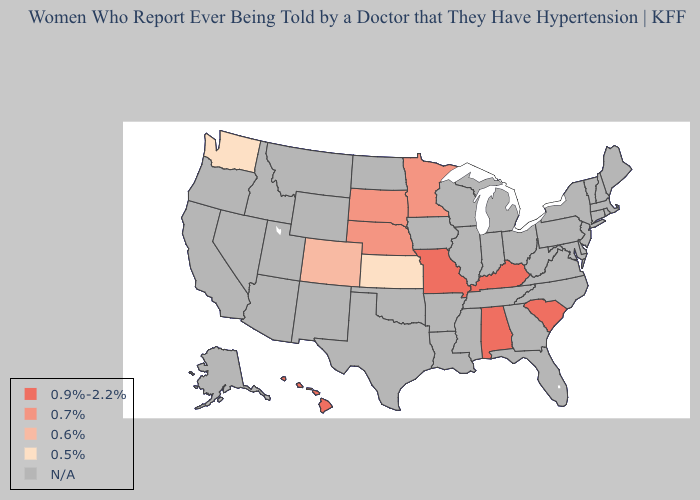What is the lowest value in the USA?
Quick response, please. 0.5%. Does Hawaii have the lowest value in the West?
Be succinct. No. Name the states that have a value in the range N/A?
Keep it brief. Alaska, Arizona, Arkansas, California, Connecticut, Delaware, Florida, Georgia, Idaho, Illinois, Indiana, Iowa, Louisiana, Maine, Maryland, Massachusetts, Michigan, Mississippi, Montana, Nevada, New Hampshire, New Jersey, New Mexico, New York, North Carolina, North Dakota, Ohio, Oklahoma, Oregon, Pennsylvania, Rhode Island, Tennessee, Texas, Utah, Vermont, Virginia, West Virginia, Wisconsin, Wyoming. Name the states that have a value in the range 0.9%-2.2%?
Be succinct. Alabama, Hawaii, Kentucky, Missouri, South Carolina. What is the lowest value in the USA?
Quick response, please. 0.5%. Name the states that have a value in the range N/A?
Short answer required. Alaska, Arizona, Arkansas, California, Connecticut, Delaware, Florida, Georgia, Idaho, Illinois, Indiana, Iowa, Louisiana, Maine, Maryland, Massachusetts, Michigan, Mississippi, Montana, Nevada, New Hampshire, New Jersey, New Mexico, New York, North Carolina, North Dakota, Ohio, Oklahoma, Oregon, Pennsylvania, Rhode Island, Tennessee, Texas, Utah, Vermont, Virginia, West Virginia, Wisconsin, Wyoming. What is the highest value in states that border Arkansas?
Answer briefly. 0.9%-2.2%. Which states have the lowest value in the USA?
Give a very brief answer. Kansas, Washington. What is the value of Hawaii?
Answer briefly. 0.9%-2.2%. What is the value of Arkansas?
Keep it brief. N/A. What is the value of Maryland?
Short answer required. N/A. What is the value of New Hampshire?
Answer briefly. N/A. Name the states that have a value in the range N/A?
Keep it brief. Alaska, Arizona, Arkansas, California, Connecticut, Delaware, Florida, Georgia, Idaho, Illinois, Indiana, Iowa, Louisiana, Maine, Maryland, Massachusetts, Michigan, Mississippi, Montana, Nevada, New Hampshire, New Jersey, New Mexico, New York, North Carolina, North Dakota, Ohio, Oklahoma, Oregon, Pennsylvania, Rhode Island, Tennessee, Texas, Utah, Vermont, Virginia, West Virginia, Wisconsin, Wyoming. Name the states that have a value in the range 0.7%?
Give a very brief answer. Minnesota, Nebraska, South Dakota. 